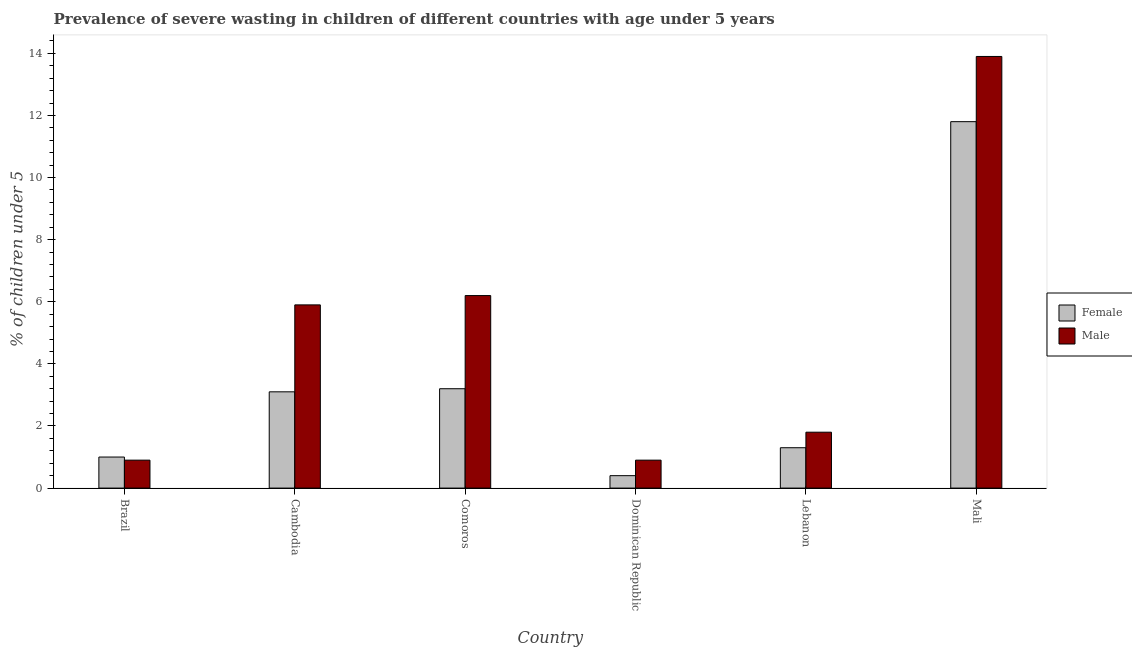How many groups of bars are there?
Your response must be concise. 6. Are the number of bars per tick equal to the number of legend labels?
Your answer should be compact. Yes. How many bars are there on the 4th tick from the left?
Offer a very short reply. 2. How many bars are there on the 6th tick from the right?
Provide a short and direct response. 2. What is the label of the 4th group of bars from the left?
Provide a succinct answer. Dominican Republic. In how many cases, is the number of bars for a given country not equal to the number of legend labels?
Offer a very short reply. 0. What is the percentage of undernourished male children in Dominican Republic?
Ensure brevity in your answer.  0.9. Across all countries, what is the maximum percentage of undernourished female children?
Ensure brevity in your answer.  11.8. Across all countries, what is the minimum percentage of undernourished female children?
Your answer should be very brief. 0.4. In which country was the percentage of undernourished male children maximum?
Ensure brevity in your answer.  Mali. In which country was the percentage of undernourished female children minimum?
Provide a short and direct response. Dominican Republic. What is the total percentage of undernourished male children in the graph?
Offer a very short reply. 29.6. What is the difference between the percentage of undernourished male children in Dominican Republic and that in Mali?
Your answer should be very brief. -13. What is the difference between the percentage of undernourished male children in Brazil and the percentage of undernourished female children in Dominican Republic?
Provide a short and direct response. 0.5. What is the average percentage of undernourished female children per country?
Your answer should be compact. 3.47. What is the difference between the percentage of undernourished male children and percentage of undernourished female children in Mali?
Offer a terse response. 2.1. What is the ratio of the percentage of undernourished male children in Brazil to that in Lebanon?
Offer a very short reply. 0.5. Is the difference between the percentage of undernourished male children in Brazil and Lebanon greater than the difference between the percentage of undernourished female children in Brazil and Lebanon?
Provide a succinct answer. No. What is the difference between the highest and the second highest percentage of undernourished female children?
Your answer should be compact. 8.6. What is the difference between the highest and the lowest percentage of undernourished female children?
Your answer should be very brief. 11.4. In how many countries, is the percentage of undernourished male children greater than the average percentage of undernourished male children taken over all countries?
Your answer should be very brief. 3. What does the 1st bar from the left in Lebanon represents?
Provide a short and direct response. Female. Are all the bars in the graph horizontal?
Keep it short and to the point. No. Does the graph contain any zero values?
Your response must be concise. No. How many legend labels are there?
Make the answer very short. 2. How are the legend labels stacked?
Keep it short and to the point. Vertical. What is the title of the graph?
Keep it short and to the point. Prevalence of severe wasting in children of different countries with age under 5 years. Does "Time to import" appear as one of the legend labels in the graph?
Your response must be concise. No. What is the label or title of the X-axis?
Ensure brevity in your answer.  Country. What is the label or title of the Y-axis?
Offer a terse response.  % of children under 5. What is the  % of children under 5 of Male in Brazil?
Provide a succinct answer. 0.9. What is the  % of children under 5 of Female in Cambodia?
Ensure brevity in your answer.  3.1. What is the  % of children under 5 in Male in Cambodia?
Provide a succinct answer. 5.9. What is the  % of children under 5 in Female in Comoros?
Your response must be concise. 3.2. What is the  % of children under 5 of Male in Comoros?
Make the answer very short. 6.2. What is the  % of children under 5 in Female in Dominican Republic?
Keep it short and to the point. 0.4. What is the  % of children under 5 in Male in Dominican Republic?
Make the answer very short. 0.9. What is the  % of children under 5 in Female in Lebanon?
Give a very brief answer. 1.3. What is the  % of children under 5 in Male in Lebanon?
Offer a terse response. 1.8. What is the  % of children under 5 of Female in Mali?
Give a very brief answer. 11.8. What is the  % of children under 5 in Male in Mali?
Your response must be concise. 13.9. Across all countries, what is the maximum  % of children under 5 of Female?
Provide a succinct answer. 11.8. Across all countries, what is the maximum  % of children under 5 of Male?
Make the answer very short. 13.9. Across all countries, what is the minimum  % of children under 5 of Female?
Provide a short and direct response. 0.4. Across all countries, what is the minimum  % of children under 5 of Male?
Give a very brief answer. 0.9. What is the total  % of children under 5 of Female in the graph?
Offer a very short reply. 20.8. What is the total  % of children under 5 of Male in the graph?
Your answer should be very brief. 29.6. What is the difference between the  % of children under 5 in Female in Brazil and that in Comoros?
Offer a terse response. -2.2. What is the difference between the  % of children under 5 in Male in Brazil and that in Comoros?
Provide a short and direct response. -5.3. What is the difference between the  % of children under 5 of Female in Brazil and that in Dominican Republic?
Ensure brevity in your answer.  0.6. What is the difference between the  % of children under 5 of Male in Brazil and that in Dominican Republic?
Offer a very short reply. 0. What is the difference between the  % of children under 5 in Female in Brazil and that in Lebanon?
Make the answer very short. -0.3. What is the difference between the  % of children under 5 of Male in Brazil and that in Lebanon?
Your response must be concise. -0.9. What is the difference between the  % of children under 5 in Female in Brazil and that in Mali?
Your answer should be very brief. -10.8. What is the difference between the  % of children under 5 in Male in Brazil and that in Mali?
Give a very brief answer. -13. What is the difference between the  % of children under 5 in Female in Cambodia and that in Comoros?
Keep it short and to the point. -0.1. What is the difference between the  % of children under 5 in Female in Cambodia and that in Dominican Republic?
Provide a succinct answer. 2.7. What is the difference between the  % of children under 5 in Female in Cambodia and that in Mali?
Ensure brevity in your answer.  -8.7. What is the difference between the  % of children under 5 of Male in Comoros and that in Lebanon?
Provide a succinct answer. 4.4. What is the difference between the  % of children under 5 of Female in Comoros and that in Mali?
Your answer should be very brief. -8.6. What is the difference between the  % of children under 5 in Female in Lebanon and that in Mali?
Offer a very short reply. -10.5. What is the difference between the  % of children under 5 in Male in Lebanon and that in Mali?
Offer a terse response. -12.1. What is the difference between the  % of children under 5 in Female in Brazil and the  % of children under 5 in Male in Lebanon?
Make the answer very short. -0.8. What is the difference between the  % of children under 5 in Female in Brazil and the  % of children under 5 in Male in Mali?
Provide a short and direct response. -12.9. What is the difference between the  % of children under 5 in Female in Cambodia and the  % of children under 5 in Male in Comoros?
Ensure brevity in your answer.  -3.1. What is the difference between the  % of children under 5 of Female in Cambodia and the  % of children under 5 of Male in Dominican Republic?
Offer a terse response. 2.2. What is the difference between the  % of children under 5 in Female in Comoros and the  % of children under 5 in Male in Dominican Republic?
Your answer should be compact. 2.3. What is the difference between the  % of children under 5 of Female in Comoros and the  % of children under 5 of Male in Mali?
Your response must be concise. -10.7. What is the difference between the  % of children under 5 of Female in Dominican Republic and the  % of children under 5 of Male in Lebanon?
Your answer should be compact. -1.4. What is the difference between the  % of children under 5 in Female in Dominican Republic and the  % of children under 5 in Male in Mali?
Provide a succinct answer. -13.5. What is the average  % of children under 5 of Female per country?
Your response must be concise. 3.47. What is the average  % of children under 5 in Male per country?
Offer a very short reply. 4.93. What is the difference between the  % of children under 5 in Female and  % of children under 5 in Male in Brazil?
Your answer should be very brief. 0.1. What is the difference between the  % of children under 5 of Female and  % of children under 5 of Male in Cambodia?
Give a very brief answer. -2.8. What is the difference between the  % of children under 5 of Female and  % of children under 5 of Male in Comoros?
Provide a succinct answer. -3. What is the difference between the  % of children under 5 of Female and  % of children under 5 of Male in Lebanon?
Offer a very short reply. -0.5. What is the difference between the  % of children under 5 in Female and  % of children under 5 in Male in Mali?
Offer a very short reply. -2.1. What is the ratio of the  % of children under 5 in Female in Brazil to that in Cambodia?
Provide a succinct answer. 0.32. What is the ratio of the  % of children under 5 in Male in Brazil to that in Cambodia?
Provide a short and direct response. 0.15. What is the ratio of the  % of children under 5 of Female in Brazil to that in Comoros?
Your answer should be very brief. 0.31. What is the ratio of the  % of children under 5 in Male in Brazil to that in Comoros?
Keep it short and to the point. 0.15. What is the ratio of the  % of children under 5 of Female in Brazil to that in Lebanon?
Make the answer very short. 0.77. What is the ratio of the  % of children under 5 in Female in Brazil to that in Mali?
Offer a very short reply. 0.08. What is the ratio of the  % of children under 5 of Male in Brazil to that in Mali?
Your answer should be compact. 0.06. What is the ratio of the  % of children under 5 in Female in Cambodia to that in Comoros?
Offer a very short reply. 0.97. What is the ratio of the  % of children under 5 in Male in Cambodia to that in Comoros?
Offer a terse response. 0.95. What is the ratio of the  % of children under 5 of Female in Cambodia to that in Dominican Republic?
Make the answer very short. 7.75. What is the ratio of the  % of children under 5 of Male in Cambodia to that in Dominican Republic?
Make the answer very short. 6.56. What is the ratio of the  % of children under 5 in Female in Cambodia to that in Lebanon?
Your answer should be compact. 2.38. What is the ratio of the  % of children under 5 of Male in Cambodia to that in Lebanon?
Your answer should be compact. 3.28. What is the ratio of the  % of children under 5 of Female in Cambodia to that in Mali?
Your answer should be very brief. 0.26. What is the ratio of the  % of children under 5 in Male in Cambodia to that in Mali?
Give a very brief answer. 0.42. What is the ratio of the  % of children under 5 in Female in Comoros to that in Dominican Republic?
Provide a succinct answer. 8. What is the ratio of the  % of children under 5 in Male in Comoros to that in Dominican Republic?
Give a very brief answer. 6.89. What is the ratio of the  % of children under 5 of Female in Comoros to that in Lebanon?
Offer a very short reply. 2.46. What is the ratio of the  % of children under 5 in Male in Comoros to that in Lebanon?
Provide a succinct answer. 3.44. What is the ratio of the  % of children under 5 of Female in Comoros to that in Mali?
Your answer should be compact. 0.27. What is the ratio of the  % of children under 5 in Male in Comoros to that in Mali?
Your answer should be very brief. 0.45. What is the ratio of the  % of children under 5 in Female in Dominican Republic to that in Lebanon?
Provide a short and direct response. 0.31. What is the ratio of the  % of children under 5 of Female in Dominican Republic to that in Mali?
Keep it short and to the point. 0.03. What is the ratio of the  % of children under 5 of Male in Dominican Republic to that in Mali?
Make the answer very short. 0.06. What is the ratio of the  % of children under 5 in Female in Lebanon to that in Mali?
Provide a succinct answer. 0.11. What is the ratio of the  % of children under 5 in Male in Lebanon to that in Mali?
Your answer should be compact. 0.13. What is the difference between the highest and the second highest  % of children under 5 in Male?
Offer a terse response. 7.7. What is the difference between the highest and the lowest  % of children under 5 in Female?
Your answer should be very brief. 11.4. 